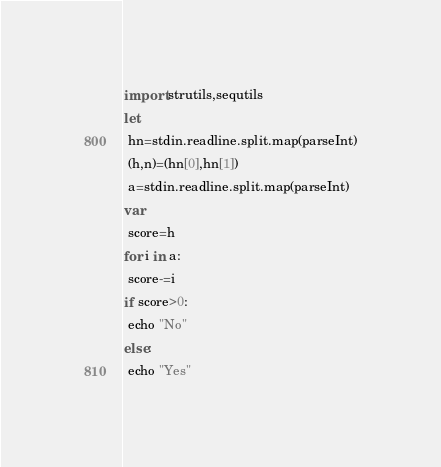<code> <loc_0><loc_0><loc_500><loc_500><_Nim_>import strutils,sequtils
let
 hn=stdin.readline.split.map(parseInt)
 (h,n)=(hn[0],hn[1])
 a=stdin.readline.split.map(parseInt)
var
 score=h
for i in a:
 score-=i
if score>0:
 echo "No"
else:
 echo "Yes"</code> 